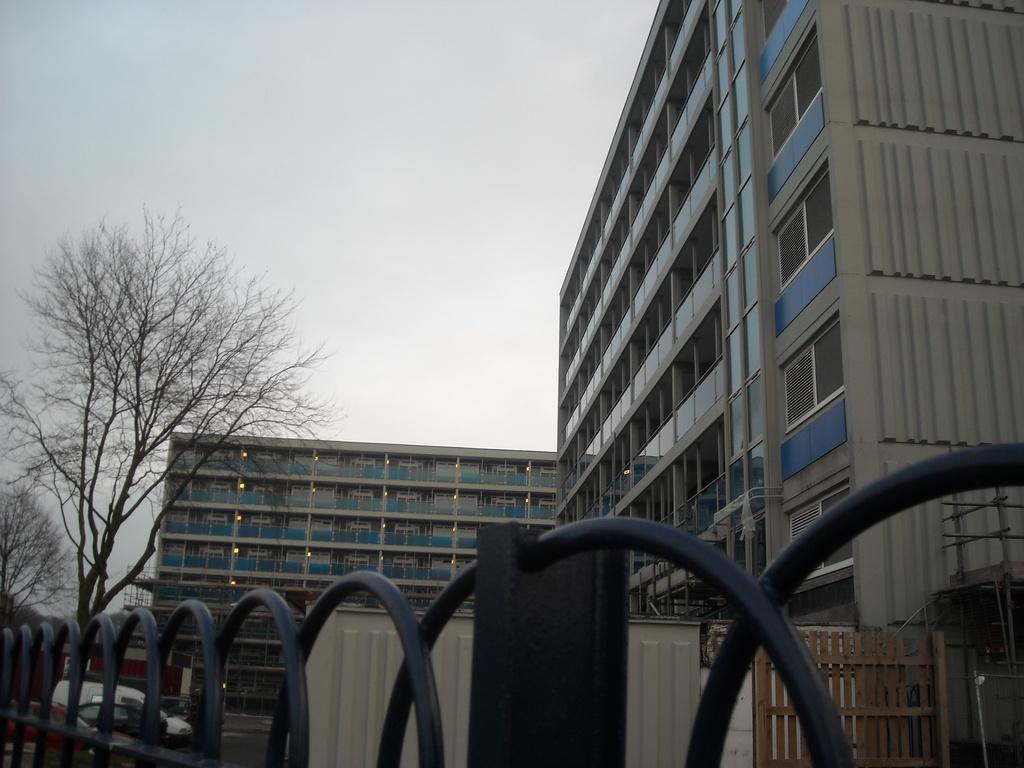What type of structures can be seen in the image? There are buildings in the image. What other natural elements are present in the image? There are trees in the image. What type of man-made objects can be seen in the image? There are vehicles in the image. What material is used for the construction of some objects in the image? Metal rods are visible in the image. What does your aunt think about the flesh in the image? There is no mention of an aunt or flesh in the image, so it is not possible to answer that question. 